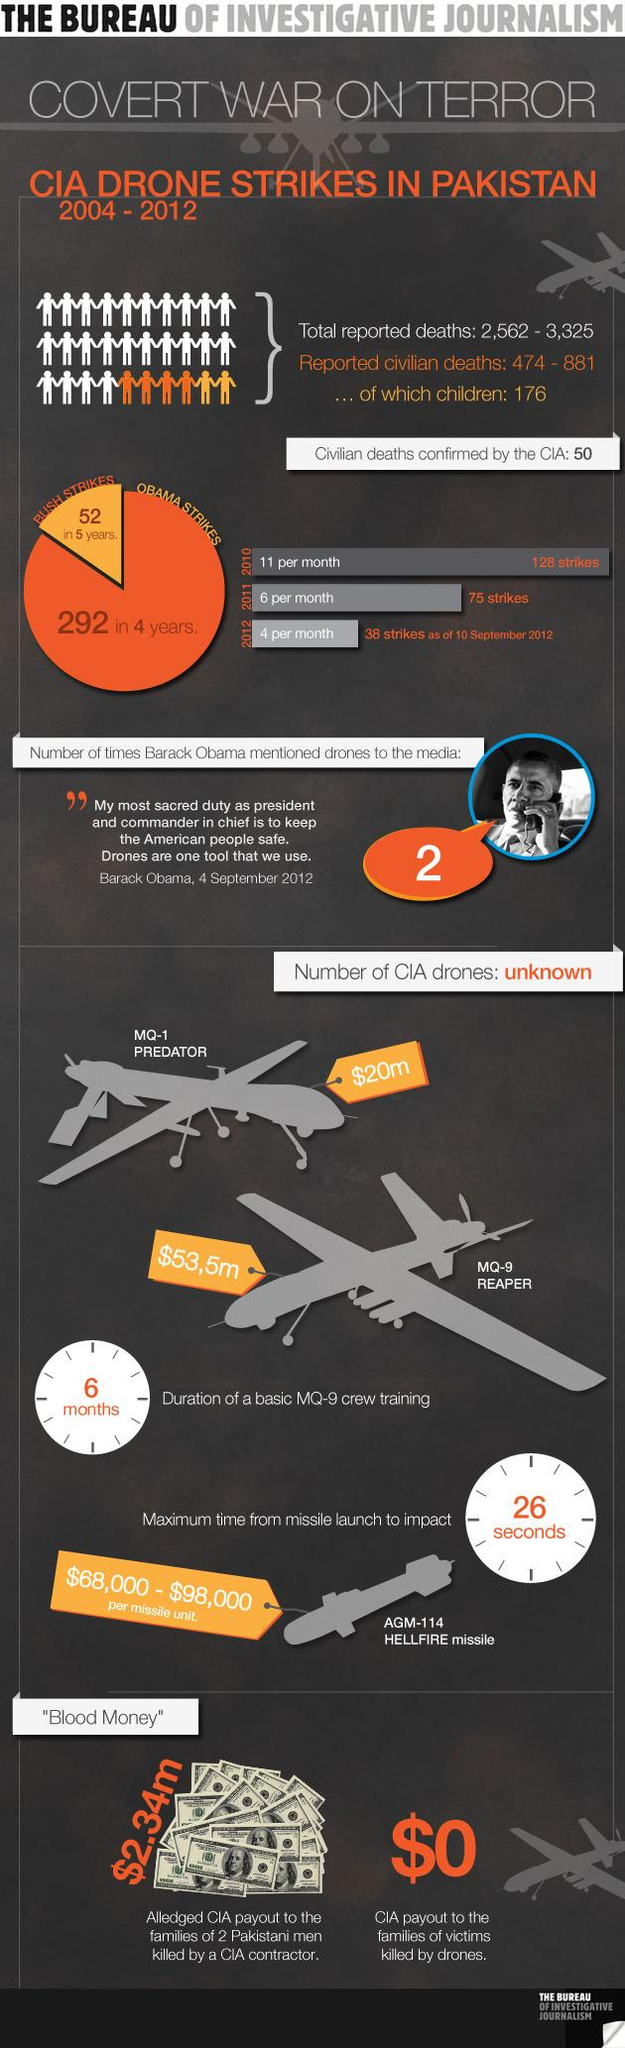Point out several critical features in this image. The cost of the MQ-9 Reaper is approximately $53.5 million. It takes approximately 6 months to train the crew of an MQ-9 unmanned aerial vehicle. The cost of the MQ-1 Predator is approximately $20 million. The CIA provides no payment to the families of victims killed by drone strikes. The per unit cost of a Hellfire missile ranges from $68,000 to $98,000. 